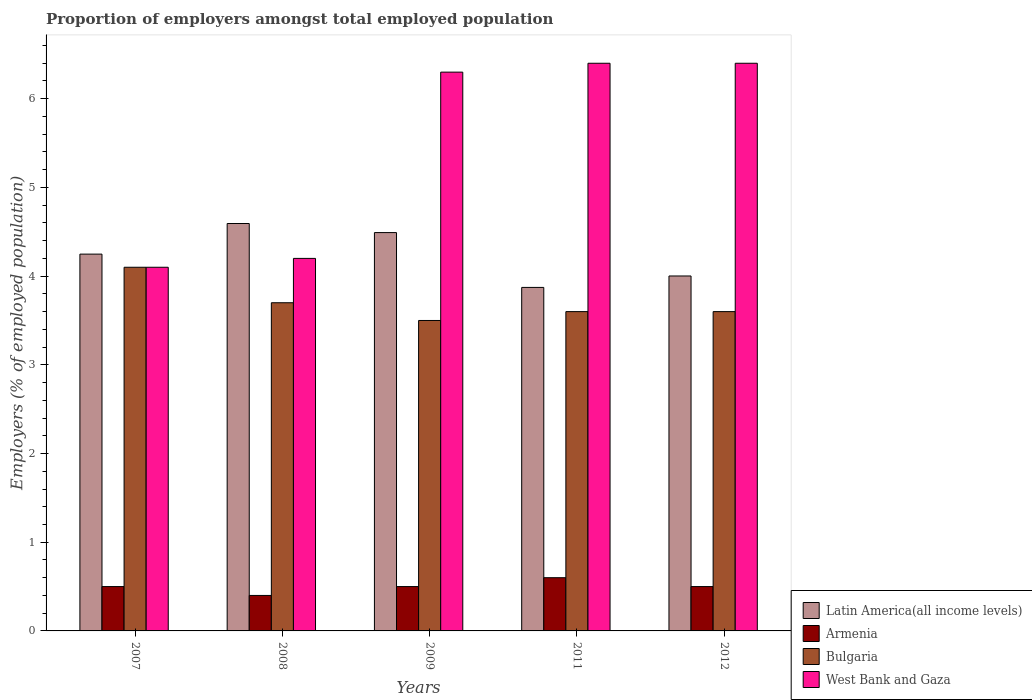How many groups of bars are there?
Ensure brevity in your answer.  5. Are the number of bars per tick equal to the number of legend labels?
Offer a very short reply. Yes. How many bars are there on the 4th tick from the right?
Keep it short and to the point. 4. In how many cases, is the number of bars for a given year not equal to the number of legend labels?
Your answer should be compact. 0. What is the proportion of employers in Bulgaria in 2012?
Provide a succinct answer. 3.6. Across all years, what is the maximum proportion of employers in Latin America(all income levels)?
Offer a very short reply. 4.59. Across all years, what is the minimum proportion of employers in Bulgaria?
Your answer should be compact. 3.5. What is the total proportion of employers in Armenia in the graph?
Make the answer very short. 2.5. What is the difference between the proportion of employers in Bulgaria in 2008 and that in 2009?
Keep it short and to the point. 0.2. What is the difference between the proportion of employers in Latin America(all income levels) in 2009 and the proportion of employers in West Bank and Gaza in 2012?
Keep it short and to the point. -1.91. What is the average proportion of employers in Armenia per year?
Your answer should be compact. 0.5. In the year 2009, what is the difference between the proportion of employers in West Bank and Gaza and proportion of employers in Bulgaria?
Offer a terse response. 2.8. In how many years, is the proportion of employers in Armenia greater than 0.2 %?
Your response must be concise. 5. What is the ratio of the proportion of employers in Bulgaria in 2007 to that in 2009?
Ensure brevity in your answer.  1.17. Is the proportion of employers in West Bank and Gaza in 2009 less than that in 2012?
Make the answer very short. Yes. What is the difference between the highest and the second highest proportion of employers in Armenia?
Provide a succinct answer. 0.1. What is the difference between the highest and the lowest proportion of employers in Bulgaria?
Give a very brief answer. 0.6. What does the 1st bar from the right in 2008 represents?
Ensure brevity in your answer.  West Bank and Gaza. Is it the case that in every year, the sum of the proportion of employers in Bulgaria and proportion of employers in Latin America(all income levels) is greater than the proportion of employers in West Bank and Gaza?
Provide a short and direct response. Yes. Are all the bars in the graph horizontal?
Provide a succinct answer. No. How many years are there in the graph?
Your answer should be compact. 5. What is the difference between two consecutive major ticks on the Y-axis?
Ensure brevity in your answer.  1. Does the graph contain any zero values?
Keep it short and to the point. No. Does the graph contain grids?
Give a very brief answer. No. How many legend labels are there?
Keep it short and to the point. 4. How are the legend labels stacked?
Your response must be concise. Vertical. What is the title of the graph?
Keep it short and to the point. Proportion of employers amongst total employed population. Does "Yemen, Rep." appear as one of the legend labels in the graph?
Give a very brief answer. No. What is the label or title of the X-axis?
Provide a short and direct response. Years. What is the label or title of the Y-axis?
Your response must be concise. Employers (% of employed population). What is the Employers (% of employed population) of Latin America(all income levels) in 2007?
Provide a succinct answer. 4.25. What is the Employers (% of employed population) in Armenia in 2007?
Your answer should be compact. 0.5. What is the Employers (% of employed population) in Bulgaria in 2007?
Make the answer very short. 4.1. What is the Employers (% of employed population) in West Bank and Gaza in 2007?
Your answer should be very brief. 4.1. What is the Employers (% of employed population) in Latin America(all income levels) in 2008?
Your answer should be compact. 4.59. What is the Employers (% of employed population) in Armenia in 2008?
Offer a terse response. 0.4. What is the Employers (% of employed population) of Bulgaria in 2008?
Keep it short and to the point. 3.7. What is the Employers (% of employed population) of West Bank and Gaza in 2008?
Give a very brief answer. 4.2. What is the Employers (% of employed population) in Latin America(all income levels) in 2009?
Your response must be concise. 4.49. What is the Employers (% of employed population) in Armenia in 2009?
Your answer should be compact. 0.5. What is the Employers (% of employed population) of Bulgaria in 2009?
Your answer should be very brief. 3.5. What is the Employers (% of employed population) in West Bank and Gaza in 2009?
Make the answer very short. 6.3. What is the Employers (% of employed population) in Latin America(all income levels) in 2011?
Provide a short and direct response. 3.87. What is the Employers (% of employed population) in Armenia in 2011?
Keep it short and to the point. 0.6. What is the Employers (% of employed population) in Bulgaria in 2011?
Offer a very short reply. 3.6. What is the Employers (% of employed population) of West Bank and Gaza in 2011?
Offer a terse response. 6.4. What is the Employers (% of employed population) in Latin America(all income levels) in 2012?
Offer a terse response. 4. What is the Employers (% of employed population) of Armenia in 2012?
Your answer should be compact. 0.5. What is the Employers (% of employed population) of Bulgaria in 2012?
Your response must be concise. 3.6. What is the Employers (% of employed population) in West Bank and Gaza in 2012?
Offer a terse response. 6.4. Across all years, what is the maximum Employers (% of employed population) in Latin America(all income levels)?
Make the answer very short. 4.59. Across all years, what is the maximum Employers (% of employed population) of Armenia?
Keep it short and to the point. 0.6. Across all years, what is the maximum Employers (% of employed population) of Bulgaria?
Ensure brevity in your answer.  4.1. Across all years, what is the maximum Employers (% of employed population) of West Bank and Gaza?
Provide a succinct answer. 6.4. Across all years, what is the minimum Employers (% of employed population) of Latin America(all income levels)?
Keep it short and to the point. 3.87. Across all years, what is the minimum Employers (% of employed population) in Armenia?
Provide a succinct answer. 0.4. Across all years, what is the minimum Employers (% of employed population) of West Bank and Gaza?
Keep it short and to the point. 4.1. What is the total Employers (% of employed population) in Latin America(all income levels) in the graph?
Your answer should be compact. 21.21. What is the total Employers (% of employed population) in West Bank and Gaza in the graph?
Keep it short and to the point. 27.4. What is the difference between the Employers (% of employed population) of Latin America(all income levels) in 2007 and that in 2008?
Your response must be concise. -0.34. What is the difference between the Employers (% of employed population) in Armenia in 2007 and that in 2008?
Your answer should be very brief. 0.1. What is the difference between the Employers (% of employed population) of West Bank and Gaza in 2007 and that in 2008?
Your response must be concise. -0.1. What is the difference between the Employers (% of employed population) of Latin America(all income levels) in 2007 and that in 2009?
Your response must be concise. -0.24. What is the difference between the Employers (% of employed population) of Bulgaria in 2007 and that in 2009?
Provide a succinct answer. 0.6. What is the difference between the Employers (% of employed population) in Latin America(all income levels) in 2007 and that in 2011?
Your answer should be very brief. 0.38. What is the difference between the Employers (% of employed population) in Latin America(all income levels) in 2007 and that in 2012?
Your response must be concise. 0.25. What is the difference between the Employers (% of employed population) of Bulgaria in 2007 and that in 2012?
Your response must be concise. 0.5. What is the difference between the Employers (% of employed population) in West Bank and Gaza in 2007 and that in 2012?
Ensure brevity in your answer.  -2.3. What is the difference between the Employers (% of employed population) of Latin America(all income levels) in 2008 and that in 2009?
Make the answer very short. 0.1. What is the difference between the Employers (% of employed population) in Armenia in 2008 and that in 2009?
Give a very brief answer. -0.1. What is the difference between the Employers (% of employed population) of West Bank and Gaza in 2008 and that in 2009?
Your answer should be compact. -2.1. What is the difference between the Employers (% of employed population) of Latin America(all income levels) in 2008 and that in 2011?
Your answer should be compact. 0.72. What is the difference between the Employers (% of employed population) in Armenia in 2008 and that in 2011?
Ensure brevity in your answer.  -0.2. What is the difference between the Employers (% of employed population) of Latin America(all income levels) in 2008 and that in 2012?
Give a very brief answer. 0.59. What is the difference between the Employers (% of employed population) in West Bank and Gaza in 2008 and that in 2012?
Your response must be concise. -2.2. What is the difference between the Employers (% of employed population) in Latin America(all income levels) in 2009 and that in 2011?
Offer a very short reply. 0.62. What is the difference between the Employers (% of employed population) of Armenia in 2009 and that in 2011?
Offer a very short reply. -0.1. What is the difference between the Employers (% of employed population) of Bulgaria in 2009 and that in 2011?
Provide a succinct answer. -0.1. What is the difference between the Employers (% of employed population) of West Bank and Gaza in 2009 and that in 2011?
Your response must be concise. -0.1. What is the difference between the Employers (% of employed population) of Latin America(all income levels) in 2009 and that in 2012?
Provide a short and direct response. 0.49. What is the difference between the Employers (% of employed population) in Armenia in 2009 and that in 2012?
Your answer should be compact. 0. What is the difference between the Employers (% of employed population) in Bulgaria in 2009 and that in 2012?
Provide a short and direct response. -0.1. What is the difference between the Employers (% of employed population) of West Bank and Gaza in 2009 and that in 2012?
Provide a short and direct response. -0.1. What is the difference between the Employers (% of employed population) of Latin America(all income levels) in 2011 and that in 2012?
Give a very brief answer. -0.13. What is the difference between the Employers (% of employed population) in Armenia in 2011 and that in 2012?
Give a very brief answer. 0.1. What is the difference between the Employers (% of employed population) in Latin America(all income levels) in 2007 and the Employers (% of employed population) in Armenia in 2008?
Your answer should be compact. 3.85. What is the difference between the Employers (% of employed population) in Latin America(all income levels) in 2007 and the Employers (% of employed population) in Bulgaria in 2008?
Offer a very short reply. 0.55. What is the difference between the Employers (% of employed population) of Latin America(all income levels) in 2007 and the Employers (% of employed population) of West Bank and Gaza in 2008?
Offer a terse response. 0.05. What is the difference between the Employers (% of employed population) of Bulgaria in 2007 and the Employers (% of employed population) of West Bank and Gaza in 2008?
Your answer should be compact. -0.1. What is the difference between the Employers (% of employed population) in Latin America(all income levels) in 2007 and the Employers (% of employed population) in Armenia in 2009?
Make the answer very short. 3.75. What is the difference between the Employers (% of employed population) in Latin America(all income levels) in 2007 and the Employers (% of employed population) in Bulgaria in 2009?
Provide a short and direct response. 0.75. What is the difference between the Employers (% of employed population) in Latin America(all income levels) in 2007 and the Employers (% of employed population) in West Bank and Gaza in 2009?
Offer a very short reply. -2.05. What is the difference between the Employers (% of employed population) of Bulgaria in 2007 and the Employers (% of employed population) of West Bank and Gaza in 2009?
Give a very brief answer. -2.2. What is the difference between the Employers (% of employed population) of Latin America(all income levels) in 2007 and the Employers (% of employed population) of Armenia in 2011?
Make the answer very short. 3.65. What is the difference between the Employers (% of employed population) in Latin America(all income levels) in 2007 and the Employers (% of employed population) in Bulgaria in 2011?
Keep it short and to the point. 0.65. What is the difference between the Employers (% of employed population) of Latin America(all income levels) in 2007 and the Employers (% of employed population) of West Bank and Gaza in 2011?
Make the answer very short. -2.15. What is the difference between the Employers (% of employed population) in Armenia in 2007 and the Employers (% of employed population) in West Bank and Gaza in 2011?
Provide a succinct answer. -5.9. What is the difference between the Employers (% of employed population) of Bulgaria in 2007 and the Employers (% of employed population) of West Bank and Gaza in 2011?
Ensure brevity in your answer.  -2.3. What is the difference between the Employers (% of employed population) in Latin America(all income levels) in 2007 and the Employers (% of employed population) in Armenia in 2012?
Your response must be concise. 3.75. What is the difference between the Employers (% of employed population) of Latin America(all income levels) in 2007 and the Employers (% of employed population) of Bulgaria in 2012?
Ensure brevity in your answer.  0.65. What is the difference between the Employers (% of employed population) of Latin America(all income levels) in 2007 and the Employers (% of employed population) of West Bank and Gaza in 2012?
Give a very brief answer. -2.15. What is the difference between the Employers (% of employed population) of Latin America(all income levels) in 2008 and the Employers (% of employed population) of Armenia in 2009?
Your answer should be compact. 4.09. What is the difference between the Employers (% of employed population) in Latin America(all income levels) in 2008 and the Employers (% of employed population) in Bulgaria in 2009?
Your answer should be compact. 1.09. What is the difference between the Employers (% of employed population) of Latin America(all income levels) in 2008 and the Employers (% of employed population) of West Bank and Gaza in 2009?
Your response must be concise. -1.71. What is the difference between the Employers (% of employed population) of Bulgaria in 2008 and the Employers (% of employed population) of West Bank and Gaza in 2009?
Keep it short and to the point. -2.6. What is the difference between the Employers (% of employed population) in Latin America(all income levels) in 2008 and the Employers (% of employed population) in Armenia in 2011?
Your response must be concise. 3.99. What is the difference between the Employers (% of employed population) of Latin America(all income levels) in 2008 and the Employers (% of employed population) of West Bank and Gaza in 2011?
Provide a succinct answer. -1.81. What is the difference between the Employers (% of employed population) in Armenia in 2008 and the Employers (% of employed population) in West Bank and Gaza in 2011?
Make the answer very short. -6. What is the difference between the Employers (% of employed population) in Latin America(all income levels) in 2008 and the Employers (% of employed population) in Armenia in 2012?
Give a very brief answer. 4.09. What is the difference between the Employers (% of employed population) in Latin America(all income levels) in 2008 and the Employers (% of employed population) in Bulgaria in 2012?
Provide a succinct answer. 0.99. What is the difference between the Employers (% of employed population) of Latin America(all income levels) in 2008 and the Employers (% of employed population) of West Bank and Gaza in 2012?
Provide a succinct answer. -1.81. What is the difference between the Employers (% of employed population) of Armenia in 2008 and the Employers (% of employed population) of West Bank and Gaza in 2012?
Offer a terse response. -6. What is the difference between the Employers (% of employed population) in Latin America(all income levels) in 2009 and the Employers (% of employed population) in Armenia in 2011?
Your response must be concise. 3.89. What is the difference between the Employers (% of employed population) of Latin America(all income levels) in 2009 and the Employers (% of employed population) of Bulgaria in 2011?
Ensure brevity in your answer.  0.89. What is the difference between the Employers (% of employed population) in Latin America(all income levels) in 2009 and the Employers (% of employed population) in West Bank and Gaza in 2011?
Give a very brief answer. -1.91. What is the difference between the Employers (% of employed population) of Armenia in 2009 and the Employers (% of employed population) of West Bank and Gaza in 2011?
Offer a terse response. -5.9. What is the difference between the Employers (% of employed population) in Bulgaria in 2009 and the Employers (% of employed population) in West Bank and Gaza in 2011?
Give a very brief answer. -2.9. What is the difference between the Employers (% of employed population) in Latin America(all income levels) in 2009 and the Employers (% of employed population) in Armenia in 2012?
Keep it short and to the point. 3.99. What is the difference between the Employers (% of employed population) in Latin America(all income levels) in 2009 and the Employers (% of employed population) in Bulgaria in 2012?
Your response must be concise. 0.89. What is the difference between the Employers (% of employed population) in Latin America(all income levels) in 2009 and the Employers (% of employed population) in West Bank and Gaza in 2012?
Offer a terse response. -1.91. What is the difference between the Employers (% of employed population) in Armenia in 2009 and the Employers (% of employed population) in West Bank and Gaza in 2012?
Your response must be concise. -5.9. What is the difference between the Employers (% of employed population) of Bulgaria in 2009 and the Employers (% of employed population) of West Bank and Gaza in 2012?
Offer a very short reply. -2.9. What is the difference between the Employers (% of employed population) of Latin America(all income levels) in 2011 and the Employers (% of employed population) of Armenia in 2012?
Keep it short and to the point. 3.37. What is the difference between the Employers (% of employed population) of Latin America(all income levels) in 2011 and the Employers (% of employed population) of Bulgaria in 2012?
Ensure brevity in your answer.  0.27. What is the difference between the Employers (% of employed population) of Latin America(all income levels) in 2011 and the Employers (% of employed population) of West Bank and Gaza in 2012?
Provide a succinct answer. -2.53. What is the average Employers (% of employed population) of Latin America(all income levels) per year?
Give a very brief answer. 4.24. What is the average Employers (% of employed population) of Armenia per year?
Make the answer very short. 0.5. What is the average Employers (% of employed population) in Bulgaria per year?
Make the answer very short. 3.7. What is the average Employers (% of employed population) of West Bank and Gaza per year?
Your response must be concise. 5.48. In the year 2007, what is the difference between the Employers (% of employed population) in Latin America(all income levels) and Employers (% of employed population) in Armenia?
Provide a succinct answer. 3.75. In the year 2007, what is the difference between the Employers (% of employed population) of Latin America(all income levels) and Employers (% of employed population) of Bulgaria?
Make the answer very short. 0.15. In the year 2007, what is the difference between the Employers (% of employed population) in Latin America(all income levels) and Employers (% of employed population) in West Bank and Gaza?
Your response must be concise. 0.15. In the year 2007, what is the difference between the Employers (% of employed population) of Armenia and Employers (% of employed population) of Bulgaria?
Ensure brevity in your answer.  -3.6. In the year 2008, what is the difference between the Employers (% of employed population) in Latin America(all income levels) and Employers (% of employed population) in Armenia?
Your response must be concise. 4.19. In the year 2008, what is the difference between the Employers (% of employed population) of Latin America(all income levels) and Employers (% of employed population) of Bulgaria?
Ensure brevity in your answer.  0.89. In the year 2008, what is the difference between the Employers (% of employed population) in Latin America(all income levels) and Employers (% of employed population) in West Bank and Gaza?
Ensure brevity in your answer.  0.39. In the year 2008, what is the difference between the Employers (% of employed population) of Bulgaria and Employers (% of employed population) of West Bank and Gaza?
Your answer should be compact. -0.5. In the year 2009, what is the difference between the Employers (% of employed population) of Latin America(all income levels) and Employers (% of employed population) of Armenia?
Provide a succinct answer. 3.99. In the year 2009, what is the difference between the Employers (% of employed population) of Latin America(all income levels) and Employers (% of employed population) of Bulgaria?
Give a very brief answer. 0.99. In the year 2009, what is the difference between the Employers (% of employed population) of Latin America(all income levels) and Employers (% of employed population) of West Bank and Gaza?
Provide a short and direct response. -1.81. In the year 2009, what is the difference between the Employers (% of employed population) in Bulgaria and Employers (% of employed population) in West Bank and Gaza?
Keep it short and to the point. -2.8. In the year 2011, what is the difference between the Employers (% of employed population) in Latin America(all income levels) and Employers (% of employed population) in Armenia?
Your answer should be compact. 3.27. In the year 2011, what is the difference between the Employers (% of employed population) of Latin America(all income levels) and Employers (% of employed population) of Bulgaria?
Offer a very short reply. 0.27. In the year 2011, what is the difference between the Employers (% of employed population) of Latin America(all income levels) and Employers (% of employed population) of West Bank and Gaza?
Provide a short and direct response. -2.53. In the year 2011, what is the difference between the Employers (% of employed population) in Armenia and Employers (% of employed population) in West Bank and Gaza?
Keep it short and to the point. -5.8. In the year 2012, what is the difference between the Employers (% of employed population) in Latin America(all income levels) and Employers (% of employed population) in Armenia?
Provide a short and direct response. 3.5. In the year 2012, what is the difference between the Employers (% of employed population) in Latin America(all income levels) and Employers (% of employed population) in Bulgaria?
Make the answer very short. 0.4. In the year 2012, what is the difference between the Employers (% of employed population) of Latin America(all income levels) and Employers (% of employed population) of West Bank and Gaza?
Your answer should be very brief. -2.4. What is the ratio of the Employers (% of employed population) of Latin America(all income levels) in 2007 to that in 2008?
Provide a short and direct response. 0.92. What is the ratio of the Employers (% of employed population) in Bulgaria in 2007 to that in 2008?
Ensure brevity in your answer.  1.11. What is the ratio of the Employers (% of employed population) of West Bank and Gaza in 2007 to that in 2008?
Your response must be concise. 0.98. What is the ratio of the Employers (% of employed population) in Latin America(all income levels) in 2007 to that in 2009?
Offer a terse response. 0.95. What is the ratio of the Employers (% of employed population) in Armenia in 2007 to that in 2009?
Offer a terse response. 1. What is the ratio of the Employers (% of employed population) of Bulgaria in 2007 to that in 2009?
Your response must be concise. 1.17. What is the ratio of the Employers (% of employed population) in West Bank and Gaza in 2007 to that in 2009?
Provide a succinct answer. 0.65. What is the ratio of the Employers (% of employed population) of Latin America(all income levels) in 2007 to that in 2011?
Provide a short and direct response. 1.1. What is the ratio of the Employers (% of employed population) in Armenia in 2007 to that in 2011?
Your answer should be compact. 0.83. What is the ratio of the Employers (% of employed population) in Bulgaria in 2007 to that in 2011?
Provide a short and direct response. 1.14. What is the ratio of the Employers (% of employed population) of West Bank and Gaza in 2007 to that in 2011?
Your response must be concise. 0.64. What is the ratio of the Employers (% of employed population) of Latin America(all income levels) in 2007 to that in 2012?
Offer a very short reply. 1.06. What is the ratio of the Employers (% of employed population) of Armenia in 2007 to that in 2012?
Provide a short and direct response. 1. What is the ratio of the Employers (% of employed population) in Bulgaria in 2007 to that in 2012?
Your response must be concise. 1.14. What is the ratio of the Employers (% of employed population) of West Bank and Gaza in 2007 to that in 2012?
Make the answer very short. 0.64. What is the ratio of the Employers (% of employed population) in Latin America(all income levels) in 2008 to that in 2009?
Provide a short and direct response. 1.02. What is the ratio of the Employers (% of employed population) of Bulgaria in 2008 to that in 2009?
Your answer should be very brief. 1.06. What is the ratio of the Employers (% of employed population) of West Bank and Gaza in 2008 to that in 2009?
Offer a very short reply. 0.67. What is the ratio of the Employers (% of employed population) of Latin America(all income levels) in 2008 to that in 2011?
Give a very brief answer. 1.19. What is the ratio of the Employers (% of employed population) in Armenia in 2008 to that in 2011?
Your answer should be very brief. 0.67. What is the ratio of the Employers (% of employed population) of Bulgaria in 2008 to that in 2011?
Ensure brevity in your answer.  1.03. What is the ratio of the Employers (% of employed population) of West Bank and Gaza in 2008 to that in 2011?
Your answer should be compact. 0.66. What is the ratio of the Employers (% of employed population) in Latin America(all income levels) in 2008 to that in 2012?
Provide a short and direct response. 1.15. What is the ratio of the Employers (% of employed population) of Bulgaria in 2008 to that in 2012?
Provide a succinct answer. 1.03. What is the ratio of the Employers (% of employed population) in West Bank and Gaza in 2008 to that in 2012?
Give a very brief answer. 0.66. What is the ratio of the Employers (% of employed population) in Latin America(all income levels) in 2009 to that in 2011?
Offer a very short reply. 1.16. What is the ratio of the Employers (% of employed population) in Armenia in 2009 to that in 2011?
Keep it short and to the point. 0.83. What is the ratio of the Employers (% of employed population) in Bulgaria in 2009 to that in 2011?
Your answer should be very brief. 0.97. What is the ratio of the Employers (% of employed population) in West Bank and Gaza in 2009 to that in 2011?
Give a very brief answer. 0.98. What is the ratio of the Employers (% of employed population) of Latin America(all income levels) in 2009 to that in 2012?
Your response must be concise. 1.12. What is the ratio of the Employers (% of employed population) of Armenia in 2009 to that in 2012?
Give a very brief answer. 1. What is the ratio of the Employers (% of employed population) of Bulgaria in 2009 to that in 2012?
Give a very brief answer. 0.97. What is the ratio of the Employers (% of employed population) of West Bank and Gaza in 2009 to that in 2012?
Give a very brief answer. 0.98. What is the ratio of the Employers (% of employed population) in Latin America(all income levels) in 2011 to that in 2012?
Ensure brevity in your answer.  0.97. What is the ratio of the Employers (% of employed population) of Bulgaria in 2011 to that in 2012?
Provide a succinct answer. 1. What is the ratio of the Employers (% of employed population) of West Bank and Gaza in 2011 to that in 2012?
Provide a succinct answer. 1. What is the difference between the highest and the second highest Employers (% of employed population) in Latin America(all income levels)?
Your answer should be compact. 0.1. What is the difference between the highest and the second highest Employers (% of employed population) of West Bank and Gaza?
Offer a very short reply. 0. What is the difference between the highest and the lowest Employers (% of employed population) in Latin America(all income levels)?
Make the answer very short. 0.72. What is the difference between the highest and the lowest Employers (% of employed population) of Armenia?
Make the answer very short. 0.2. What is the difference between the highest and the lowest Employers (% of employed population) in Bulgaria?
Offer a very short reply. 0.6. What is the difference between the highest and the lowest Employers (% of employed population) of West Bank and Gaza?
Your answer should be very brief. 2.3. 